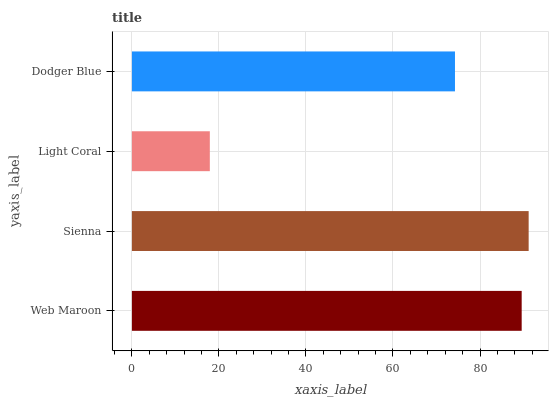Is Light Coral the minimum?
Answer yes or no. Yes. Is Sienna the maximum?
Answer yes or no. Yes. Is Sienna the minimum?
Answer yes or no. No. Is Light Coral the maximum?
Answer yes or no. No. Is Sienna greater than Light Coral?
Answer yes or no. Yes. Is Light Coral less than Sienna?
Answer yes or no. Yes. Is Light Coral greater than Sienna?
Answer yes or no. No. Is Sienna less than Light Coral?
Answer yes or no. No. Is Web Maroon the high median?
Answer yes or no. Yes. Is Dodger Blue the low median?
Answer yes or no. Yes. Is Light Coral the high median?
Answer yes or no. No. Is Sienna the low median?
Answer yes or no. No. 